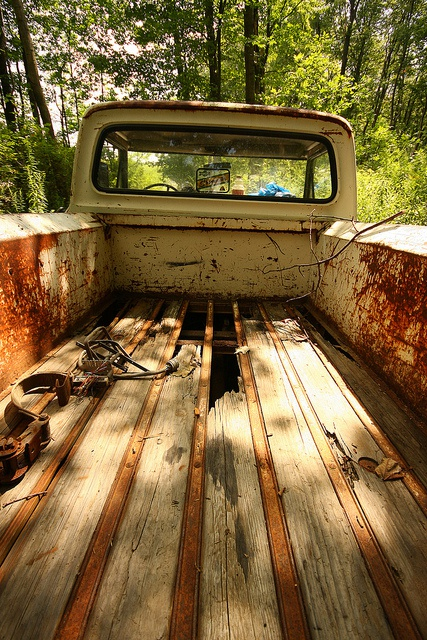Describe the objects in this image and their specific colors. I can see a truck in darkgreen, olive, black, and maroon tones in this image. 